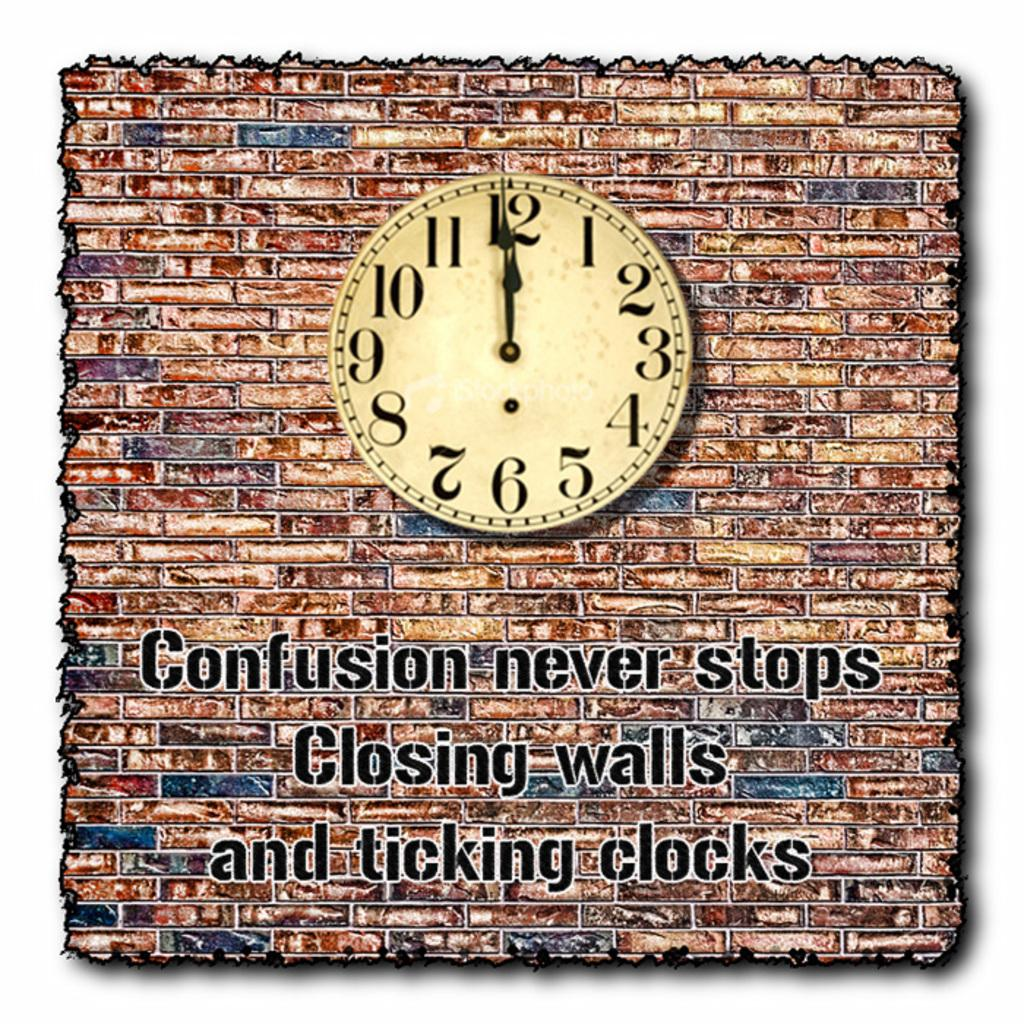<image>
Give a short and clear explanation of the subsequent image. a clock is hanging on a wall with the words Confusion never stops closing walls and ticking clocks 